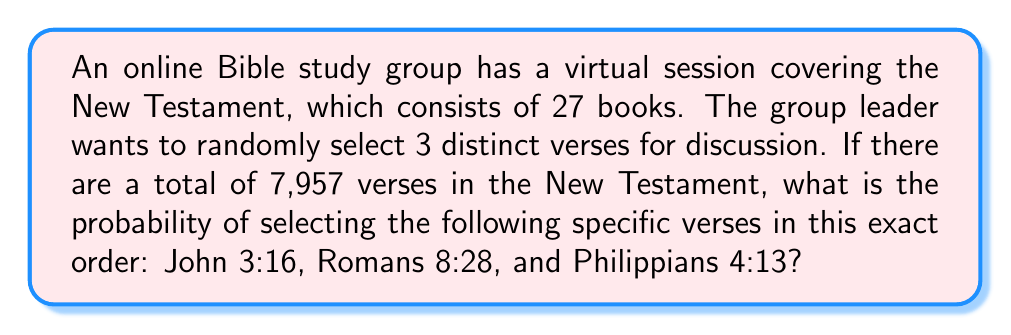Give your solution to this math problem. To solve this problem, we need to use the concept of ordered selection without replacement. Here's the step-by-step solution:

1. Total number of verses: 7,957

2. For the first selection (John 3:16):
   Probability = $\frac{1}{7957}$

3. For the second selection (Romans 8:28):
   Probability = $\frac{1}{7956}$ (because one verse has already been selected)

4. For the third selection (Philippians 4:13):
   Probability = $\frac{1}{7955}$ (because two verses have already been selected)

5. The probability of selecting these specific verses in this exact order is the product of their individual probabilities:

   $$P = \frac{1}{7957} \times \frac{1}{7956} \times \frac{1}{7955}$$

6. Calculating the result:
   $$P = \frac{1}{7957 \times 7956 \times 7955} = \frac{1}{502,619,801,220}$$

7. To express this as a decimal:
   $$P \approx 1.9896 \times 10^{-12}$$
Answer: The probability of randomly selecting John 3:16, Romans 8:28, and Philippians 4:13 in this exact order during the online Bible study session is $\frac{1}{502,619,801,220}$ or approximately $1.9896 \times 10^{-12}$. 